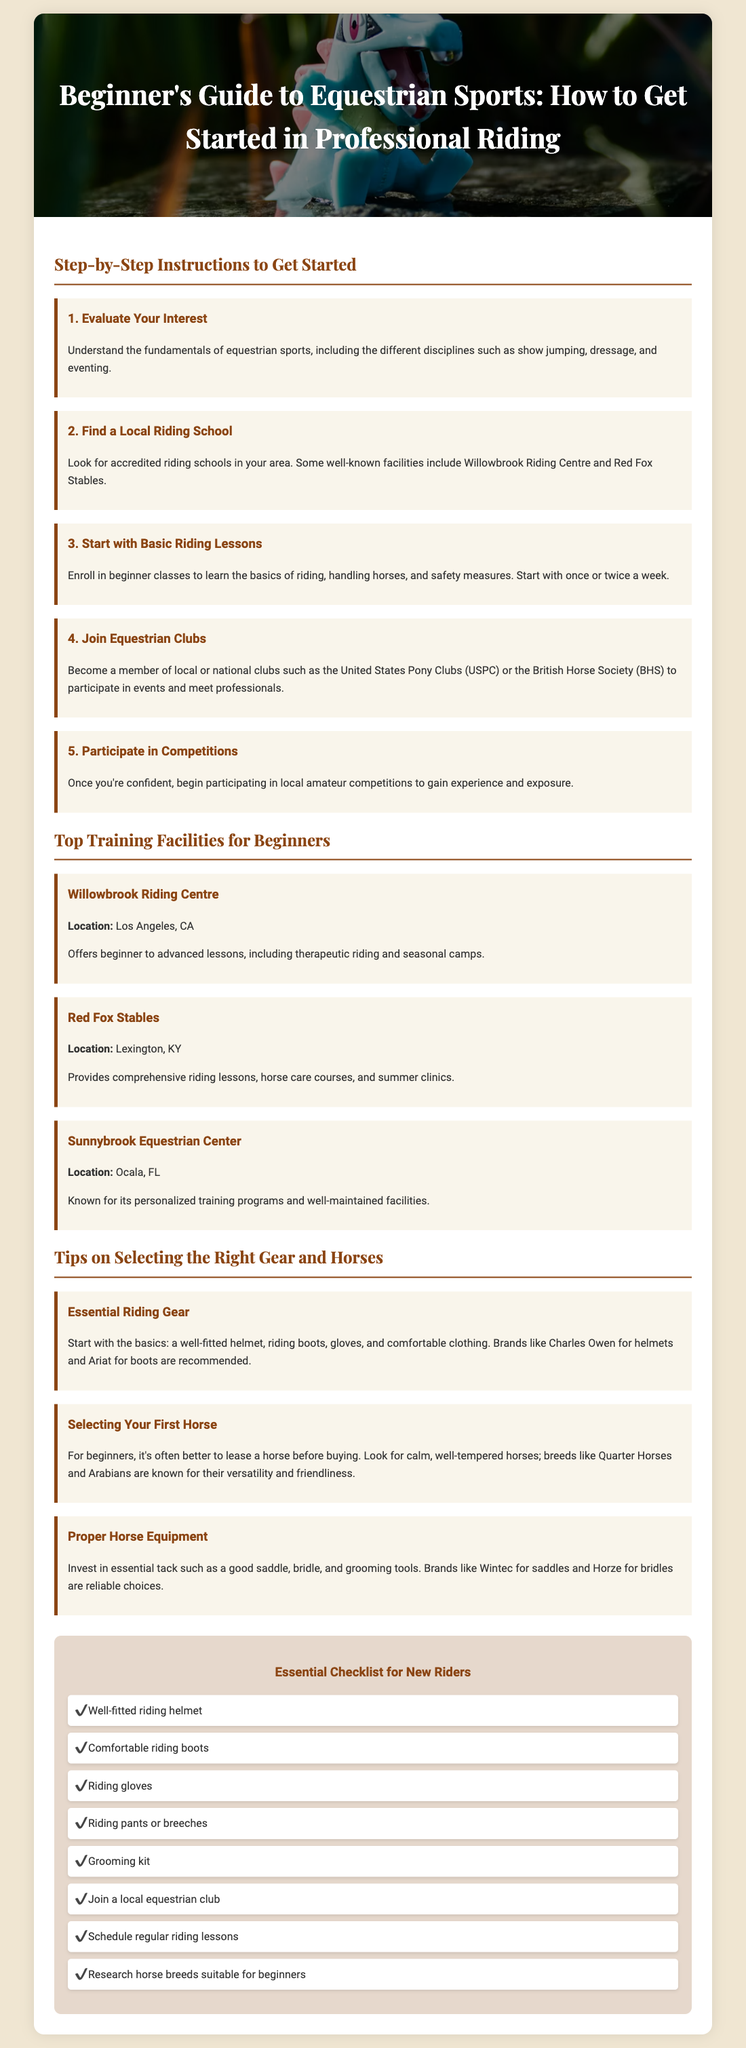What is the title of the flyer? The title is prominently displayed at the top of the document, summarizing the main content and purpose.
Answer: Beginner's Guide to Equestrian Sports: How to Get Started in Professional Riding How many steps are there to get started? The document outlines a specific sequence of steps for beginners, which is stated in a clear format.
Answer: 5 What are the names of two suggested training facilities? The flyer lists several training facilities suitable for beginners, highlighting their importance in the learning process.
Answer: Willowbrook Riding Centre, Red Fox Stables What is one recommended brand for riding helmets? The document provides specific brand recommendations for essential riding gear to assist beginners in making informed choices.
Answer: Charles Owen Which horse breeds are mentioned as suitable for beginners? The flyer emphasizes the importance of choosing the right horse for novice riders and provides examples.
Answer: Quarter Horses, Arabians What are the essential riding gear items mentioned? The checklist includes key items necessary for safe and effective riding, indicating their fundamental role in getting started.
Answer: Well-fitted helmet, riding boots, gloves, comfortable clothing How often should beginners schedule lessons according to the flyer? The document suggests a frequency for lessons as part of the initial steps for aspiring riders to foster regular practice.
Answer: Once or twice a week What is one action recommended for new riders regarding equestrian clubs? The flyer includes a call to action encouraging participation in community or professional organizations to enhance learning and networking.
Answer: Join a local equestrian club 